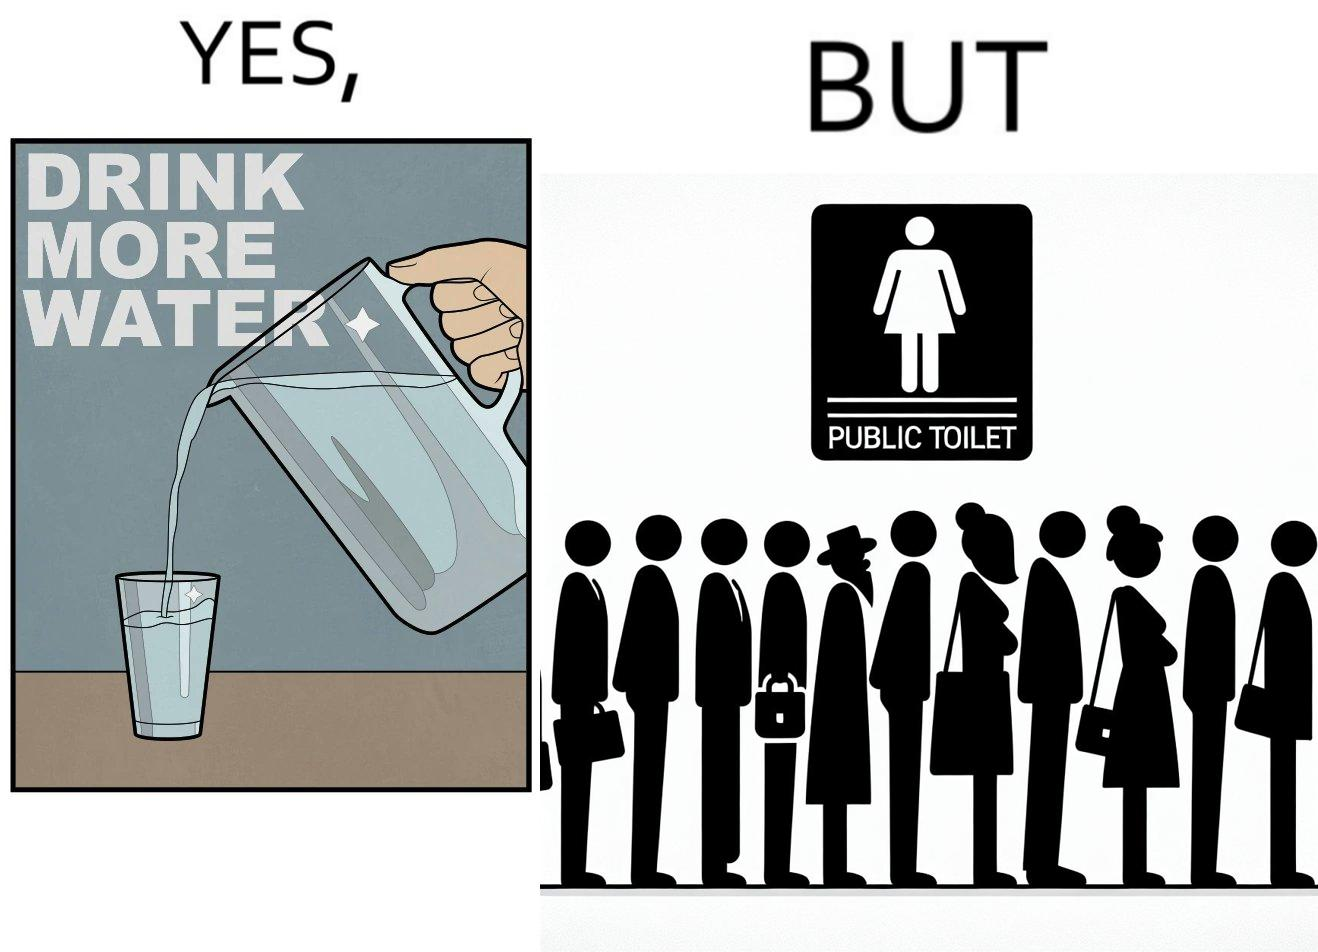Describe the contrast between the left and right parts of this image. In the left part of the image: A banner that says "Drink more water" with an image of a jug pouring water into a glass. In the right part of the image: a very long queue in front of the public toilet 